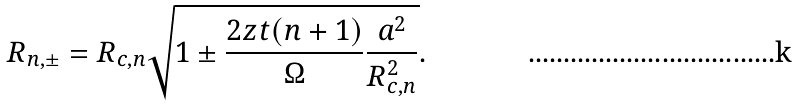Convert formula to latex. <formula><loc_0><loc_0><loc_500><loc_500>R _ { n , \pm } = R _ { c , n } \sqrt { 1 \pm \frac { 2 z t ( n + 1 ) } { \Omega } \frac { a ^ { 2 } } { R _ { c , n } ^ { 2 } } } .</formula> 